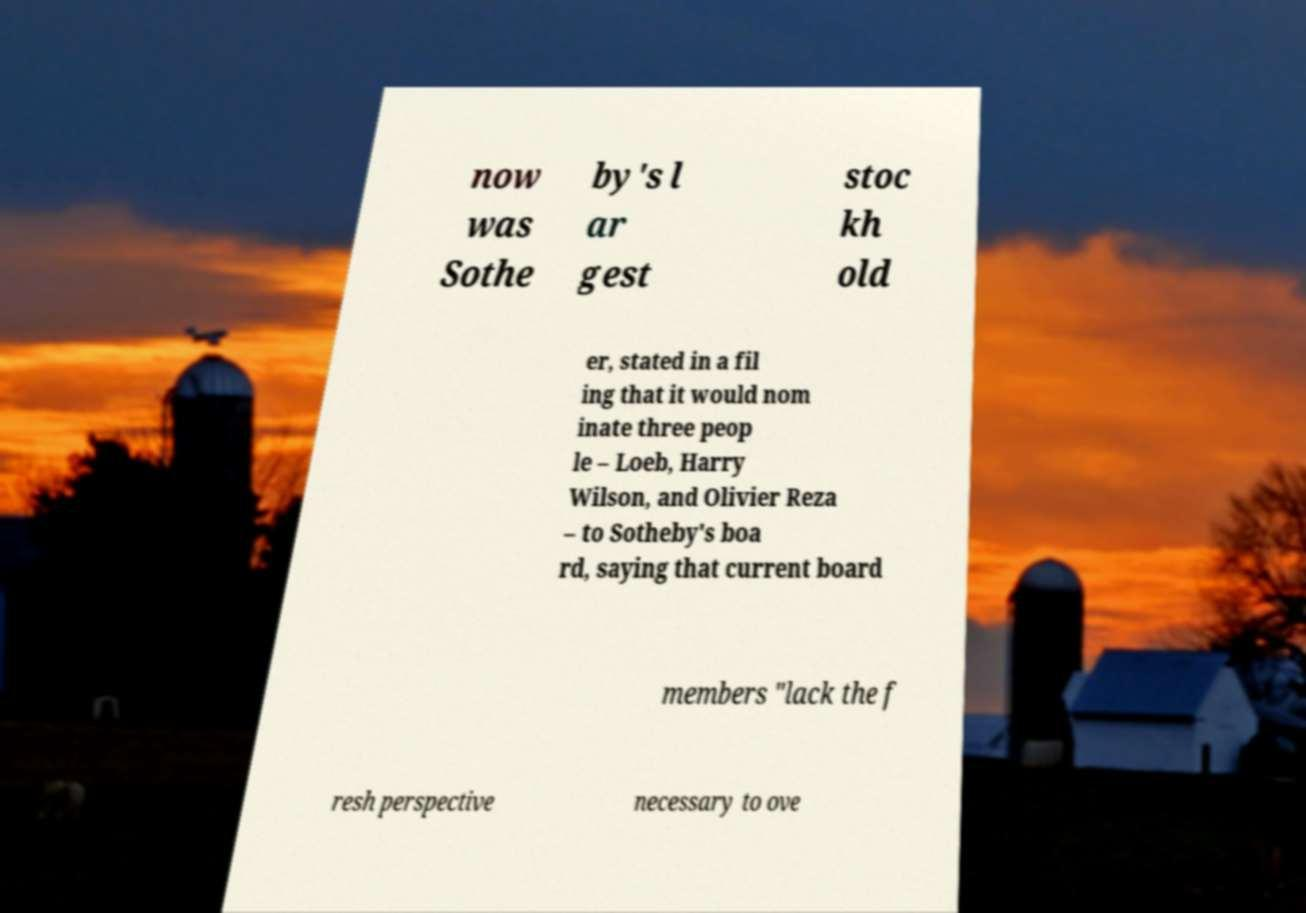Could you assist in decoding the text presented in this image and type it out clearly? now was Sothe by's l ar gest stoc kh old er, stated in a fil ing that it would nom inate three peop le – Loeb, Harry Wilson, and Olivier Reza – to Sotheby's boa rd, saying that current board members "lack the f resh perspective necessary to ove 